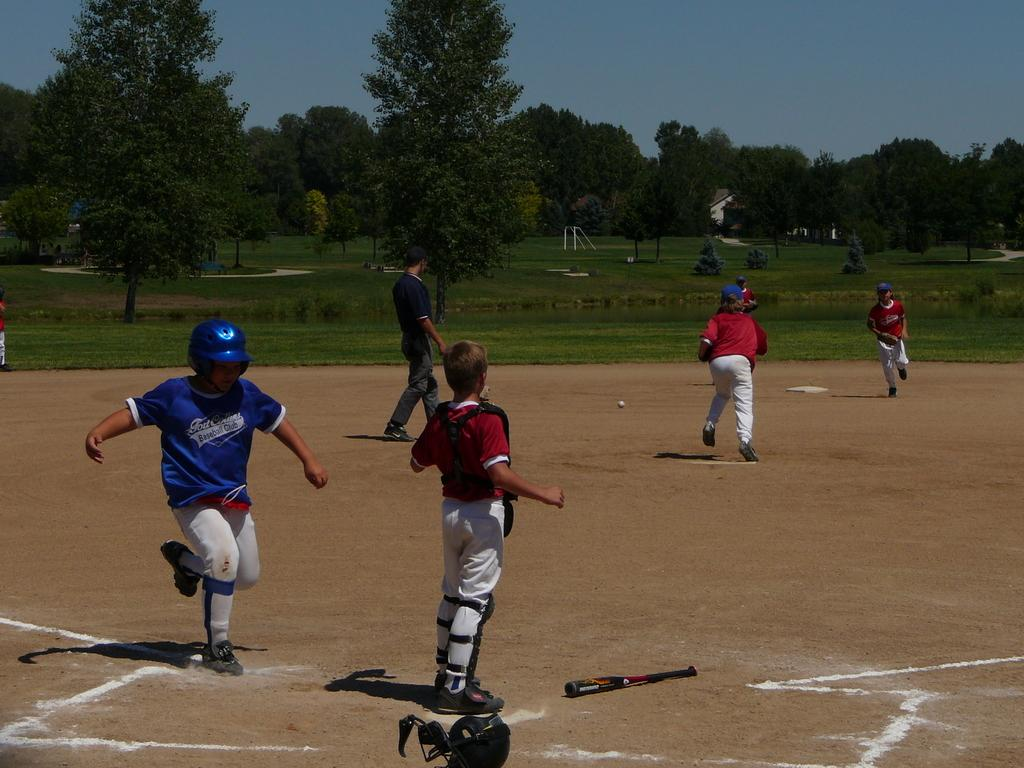<image>
Describe the image concisely. A player for the Fort Collins baseball club about to cross home during a baseball game. 